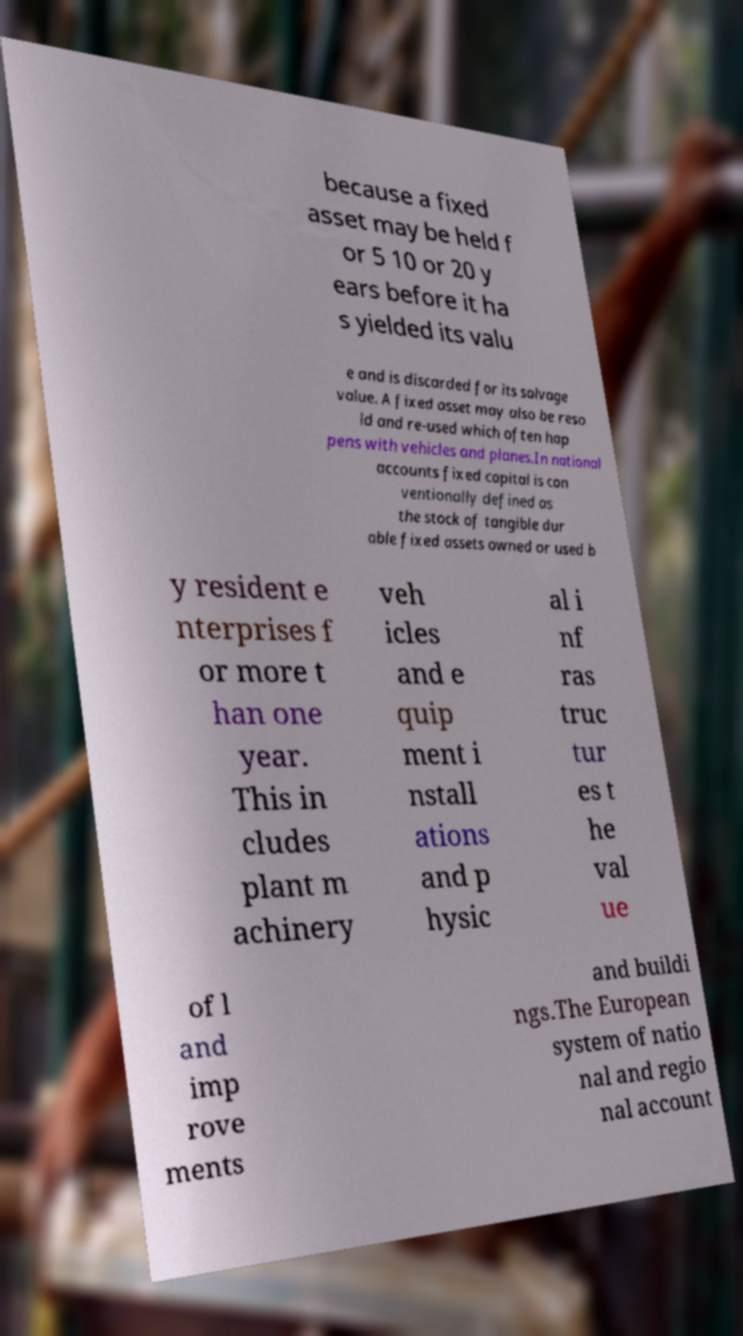Can you accurately transcribe the text from the provided image for me? because a fixed asset may be held f or 5 10 or 20 y ears before it ha s yielded its valu e and is discarded for its salvage value. A fixed asset may also be reso ld and re-used which often hap pens with vehicles and planes.In national accounts fixed capital is con ventionally defined as the stock of tangible dur able fixed assets owned or used b y resident e nterprises f or more t han one year. This in cludes plant m achinery veh icles and e quip ment i nstall ations and p hysic al i nf ras truc tur es t he val ue of l and imp rove ments and buildi ngs.The European system of natio nal and regio nal account 